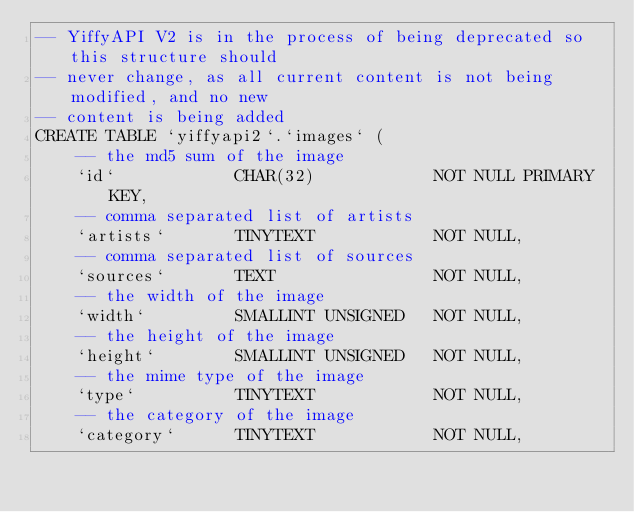<code> <loc_0><loc_0><loc_500><loc_500><_SQL_>-- YiffyAPI V2 is in the process of being deprecated so this structure should
-- never change, as all current content is not being modified, and no new
-- content is being added
CREATE TABLE `yiffyapi2`.`images` (
	-- the md5 sum of the image
	`id`            CHAR(32)            NOT NULL PRIMARY KEY,
	-- comma separated list of artists
	`artists`       TINYTEXT            NOT NULL,
	-- comma separated list of sources
	`sources`       TEXT                NOT NULL,
	-- the width of the image
	`width`         SMALLINT UNSIGNED   NOT NULL,
	-- the height of the image
	`height`        SMALLINT UNSIGNED   NOT NULL,
	-- the mime type of the image
	`type`          TINYTEXT            NOT NULL,
	-- the category of the image
	`category`      TINYTEXT            NOT NULL,</code> 